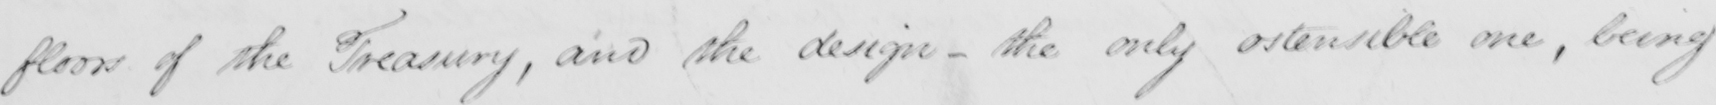What does this handwritten line say? floors of the Treasury and the design - the only ostensible one , being 